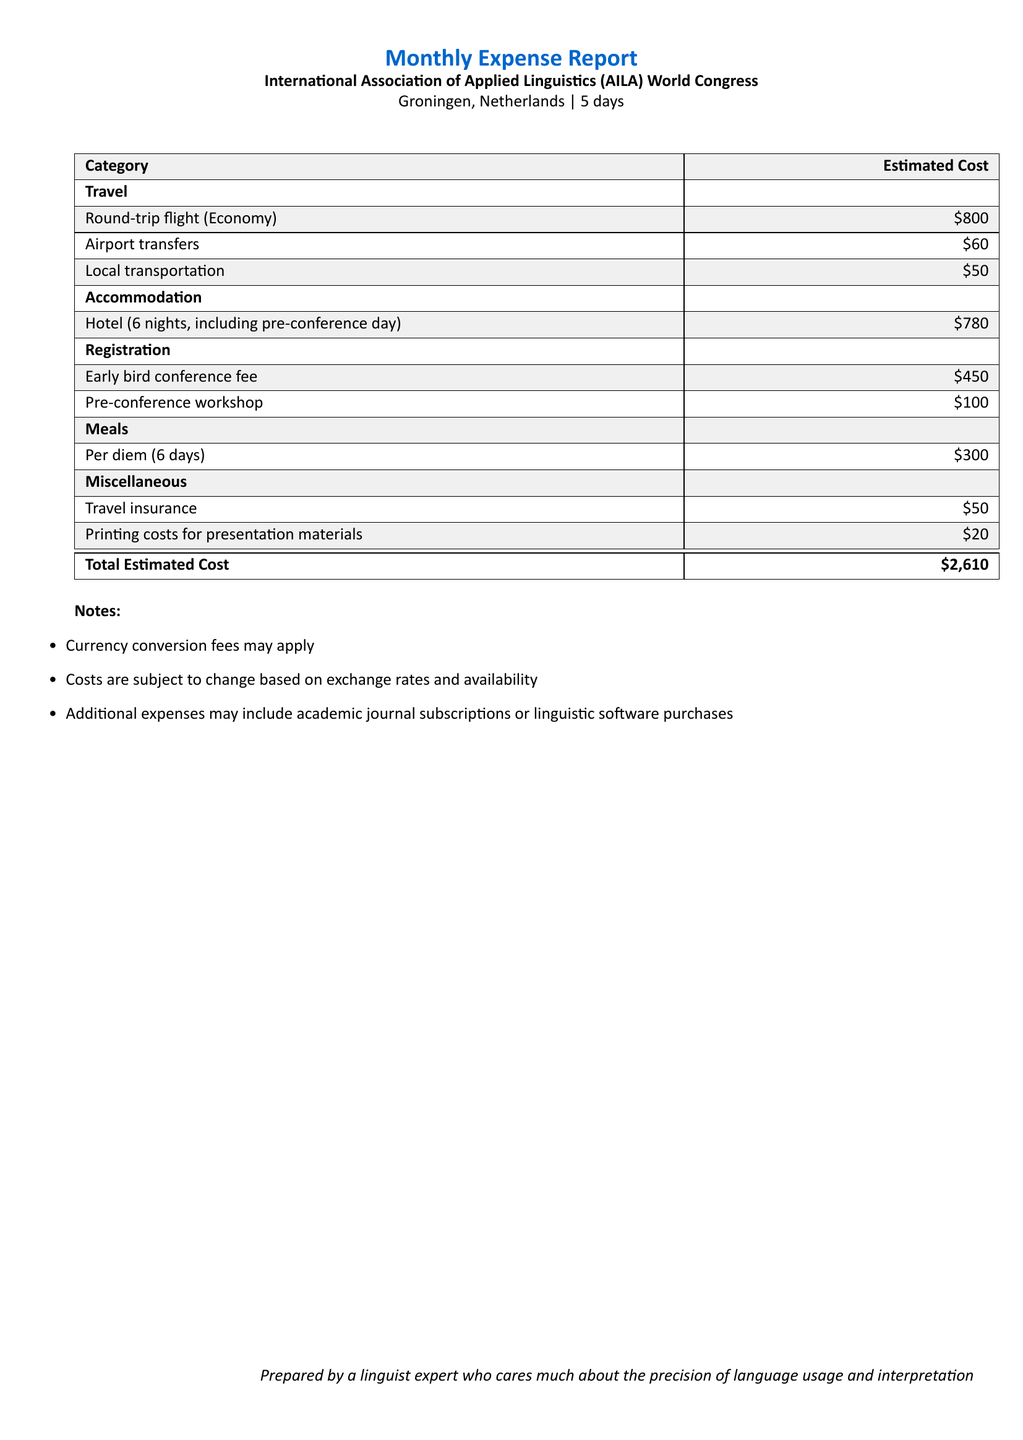What is the total estimated cost? The total estimated cost is listed at the bottom of the document, summing all expenses.
Answer: \$2,610 What is the cost of the round-trip flight? The round-trip flight cost is detailed in the travel section of the document.
Answer: \$800 How many nights is accommodation planned for? The accommodation details state that it covers 6 nights, including one pre-conference day.
Answer: 6 nights What is the early bird conference fee? The early bird conference fee is specified under the registration category in the document.
Answer: \$450 What is the total cost for meals? The cost for meals is calculated based on the per diem for 6 days.
Answer: \$300 How much is the cost for travel insurance? Travel insurance is listed in the miscellaneous category of expenses.
Answer: \$50 What type of document is this? This document is a report prepared for a budget related to attending international language conferences.
Answer: Monthly Expense Report What are potential additional expenses mentioned? Additional expenses are noted at the end of the document, including subscriptions or software purchases.
Answer: Academic journal subscriptions or linguistic software purchases What is the cost of the pre-conference workshop? The pre-conference workshop is itemized in the registration section with its cost.
Answer: \$100 